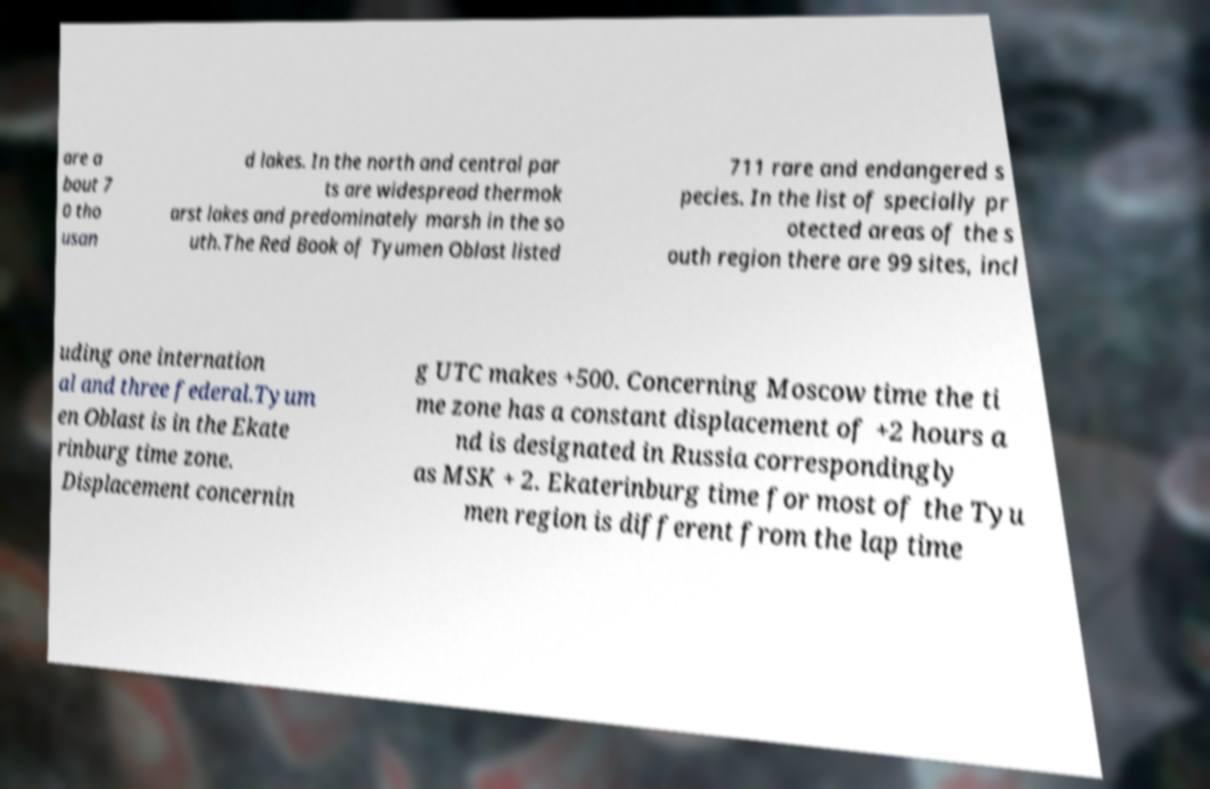There's text embedded in this image that I need extracted. Can you transcribe it verbatim? are a bout 7 0 tho usan d lakes. In the north and central par ts are widespread thermok arst lakes and predominately marsh in the so uth.The Red Book of Tyumen Oblast listed 711 rare and endangered s pecies. In the list of specially pr otected areas of the s outh region there are 99 sites, incl uding one internation al and three federal.Tyum en Oblast is in the Ekate rinburg time zone. Displacement concernin g UTC makes +500. Concerning Moscow time the ti me zone has a constant displacement of +2 hours a nd is designated in Russia correspondingly as MSK + 2. Ekaterinburg time for most of the Tyu men region is different from the lap time 